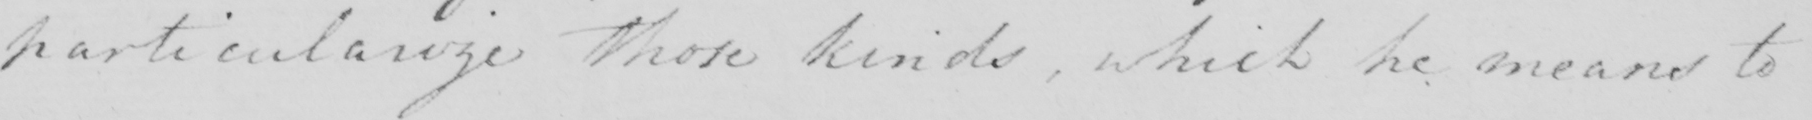What does this handwritten line say? particularize those kinds , which he means to 